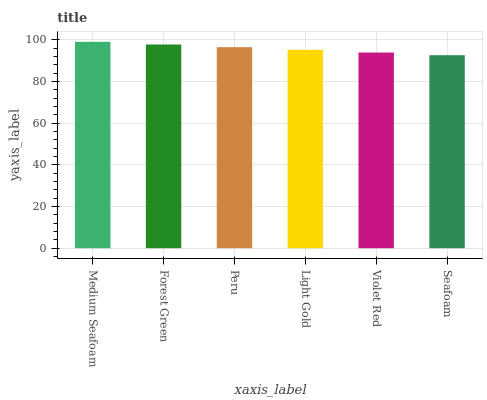Is Forest Green the minimum?
Answer yes or no. No. Is Forest Green the maximum?
Answer yes or no. No. Is Medium Seafoam greater than Forest Green?
Answer yes or no. Yes. Is Forest Green less than Medium Seafoam?
Answer yes or no. Yes. Is Forest Green greater than Medium Seafoam?
Answer yes or no. No. Is Medium Seafoam less than Forest Green?
Answer yes or no. No. Is Peru the high median?
Answer yes or no. Yes. Is Light Gold the low median?
Answer yes or no. Yes. Is Light Gold the high median?
Answer yes or no. No. Is Peru the low median?
Answer yes or no. No. 